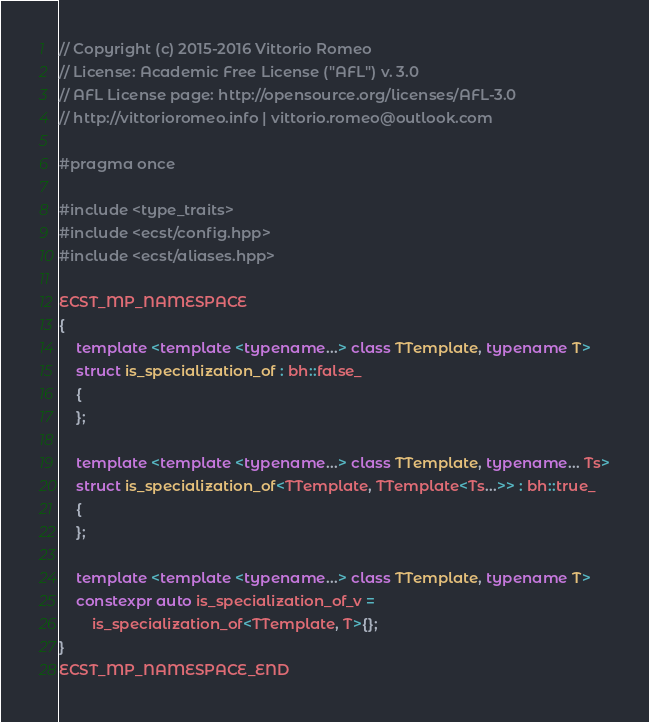Convert code to text. <code><loc_0><loc_0><loc_500><loc_500><_C++_>// Copyright (c) 2015-2016 Vittorio Romeo
// License: Academic Free License ("AFL") v. 3.0
// AFL License page: http://opensource.org/licenses/AFL-3.0
// http://vittorioromeo.info | vittorio.romeo@outlook.com

#pragma once

#include <type_traits>
#include <ecst/config.hpp>
#include <ecst/aliases.hpp>

ECST_MP_NAMESPACE
{
    template <template <typename...> class TTemplate, typename T>
    struct is_specialization_of : bh::false_
    {
    };

    template <template <typename...> class TTemplate, typename... Ts>
    struct is_specialization_of<TTemplate, TTemplate<Ts...>> : bh::true_
    {
    };

    template <template <typename...> class TTemplate, typename T>
    constexpr auto is_specialization_of_v =
        is_specialization_of<TTemplate, T>{};
}
ECST_MP_NAMESPACE_END
</code> 